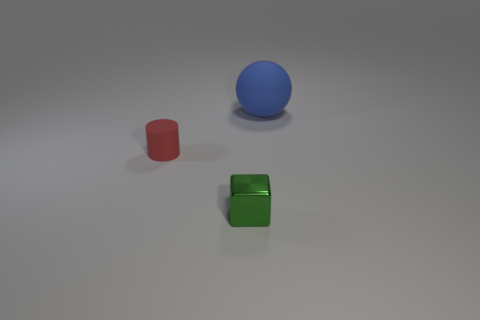Add 2 balls. How many objects exist? 5 Add 3 tiny red things. How many tiny red things are left? 4 Add 3 big objects. How many big objects exist? 4 Subtract 1 green cubes. How many objects are left? 2 Subtract all balls. How many objects are left? 2 Subtract 1 balls. How many balls are left? 0 Subtract all green balls. Subtract all cyan cylinders. How many balls are left? 1 Subtract all green cylinders. How many red spheres are left? 0 Subtract all purple matte things. Subtract all tiny red rubber cylinders. How many objects are left? 2 